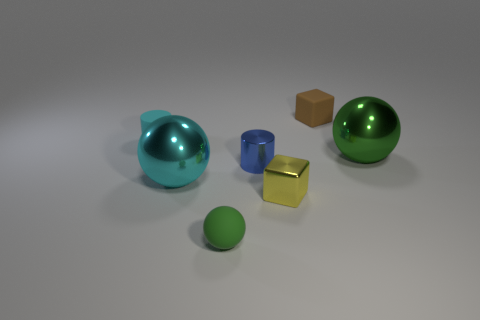What is the color of the big ball to the left of the green object that is behind the cylinder to the right of the cyan metallic thing?
Provide a short and direct response. Cyan. There is a large metal ball right of the brown cube; is it the same color as the metallic cylinder?
Provide a short and direct response. No. What number of things are both in front of the small brown rubber block and to the right of the yellow metallic cube?
Your answer should be compact. 1. There is another thing that is the same shape as the small cyan thing; what size is it?
Your response must be concise. Small. There is a large thing that is on the left side of the block in front of the blue shiny thing; how many green metallic balls are behind it?
Ensure brevity in your answer.  1. The large metal sphere on the right side of the small cube behind the rubber cylinder is what color?
Keep it short and to the point. Green. What number of other objects are there of the same material as the small ball?
Your answer should be very brief. 2. What number of rubber objects are in front of the small cylinder that is on the right side of the small cyan cylinder?
Your answer should be compact. 1. There is a big metal ball on the left side of the rubber cube; is it the same color as the tiny cylinder that is behind the green metal sphere?
Keep it short and to the point. Yes. Are there fewer shiny balls than spheres?
Provide a succinct answer. Yes. 